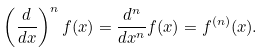<formula> <loc_0><loc_0><loc_500><loc_500>\left ( { \frac { d } { d x } } \right ) ^ { n } f ( x ) = { \frac { d ^ { n } } { d x ^ { n } } } f ( x ) = f ^ { ( n ) } ( x ) .</formula> 